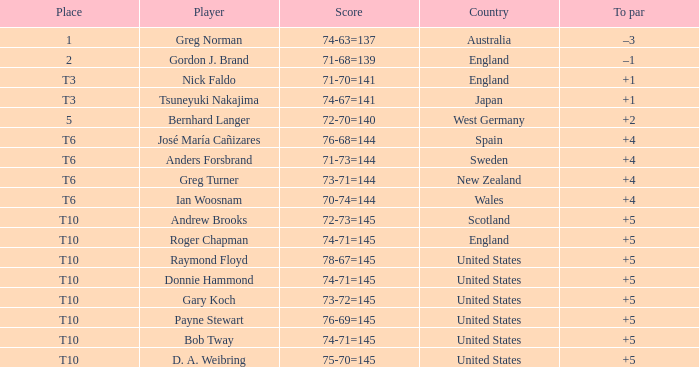What did United States place when the player was Raymond Floyd? T10. 